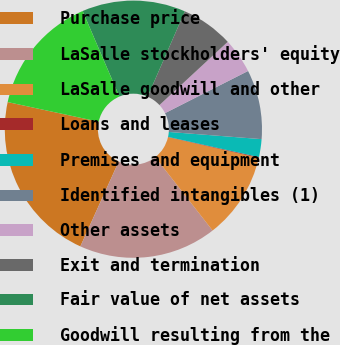Convert chart to OTSL. <chart><loc_0><loc_0><loc_500><loc_500><pie_chart><fcel>Purchase price<fcel>LaSalle stockholders' equity<fcel>LaSalle goodwill and other<fcel>Loans and leases<fcel>Premises and equipment<fcel>Identified intangibles (1)<fcel>Other assets<fcel>Exit and termination<fcel>Fair value of net assets<fcel>Goodwill resulting from the<nl><fcel>21.62%<fcel>17.32%<fcel>10.86%<fcel>0.1%<fcel>2.25%<fcel>8.71%<fcel>4.41%<fcel>6.56%<fcel>13.01%<fcel>15.16%<nl></chart> 